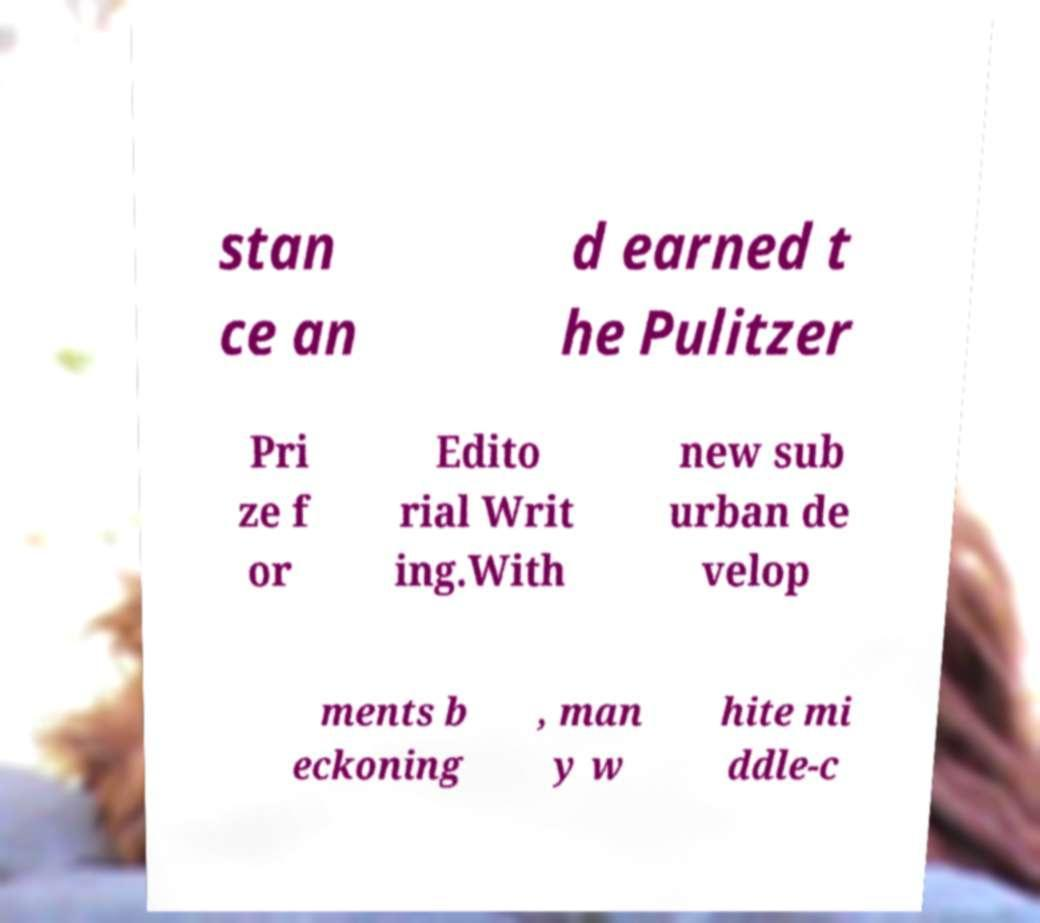What messages or text are displayed in this image? I need them in a readable, typed format. stan ce an d earned t he Pulitzer Pri ze f or Edito rial Writ ing.With new sub urban de velop ments b eckoning , man y w hite mi ddle-c 